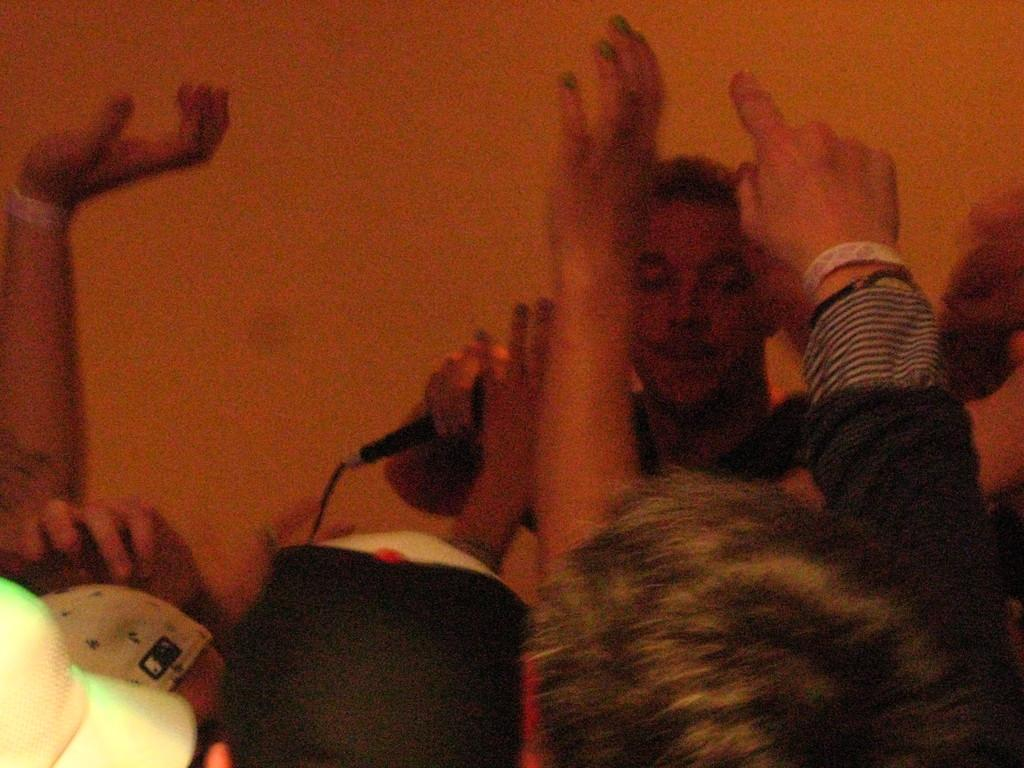How many people are in the image? There are people in the image, but the exact number is not specified. What is the man holding in his hand? One man is holding a microphone in his hand. Can you describe the attire of some people in the image? Some people are wearing caps. What type of bag is the owl carrying in the image? There is no owl or bag present in the image. 